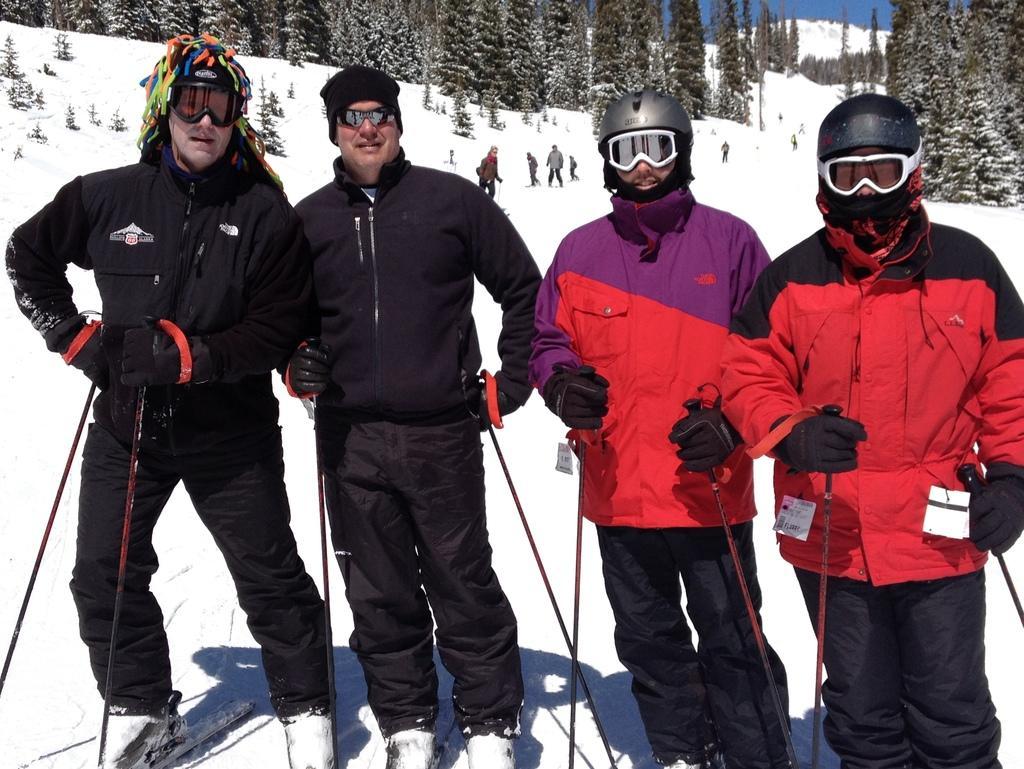Can you describe this image briefly? In this image I can see four people standing in front and they are wearing black,red and purple dress and holding sticks. Back Side I can see few people,trees and snow. The sky is in blue color. 